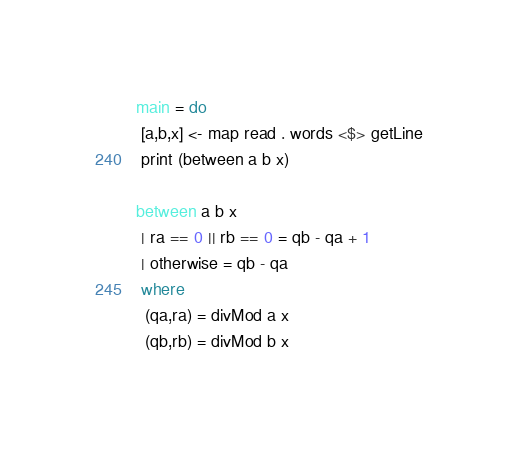Convert code to text. <code><loc_0><loc_0><loc_500><loc_500><_Haskell_>main = do
 [a,b,x] <- map read . words <$> getLine
 print (between a b x)

between a b x
 | ra == 0 || rb == 0 = qb - qa + 1
 | otherwise = qb - qa
 where
  (qa,ra) = divMod a x
  (qb,rb) = divMod b x</code> 